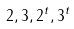Convert formula to latex. <formula><loc_0><loc_0><loc_500><loc_500>2 , 3 , 2 ^ { t } , 3 ^ { t }</formula> 